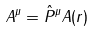Convert formula to latex. <formula><loc_0><loc_0><loc_500><loc_500>A ^ { \mu } = \hat { P } ^ { \mu } A ( r )</formula> 